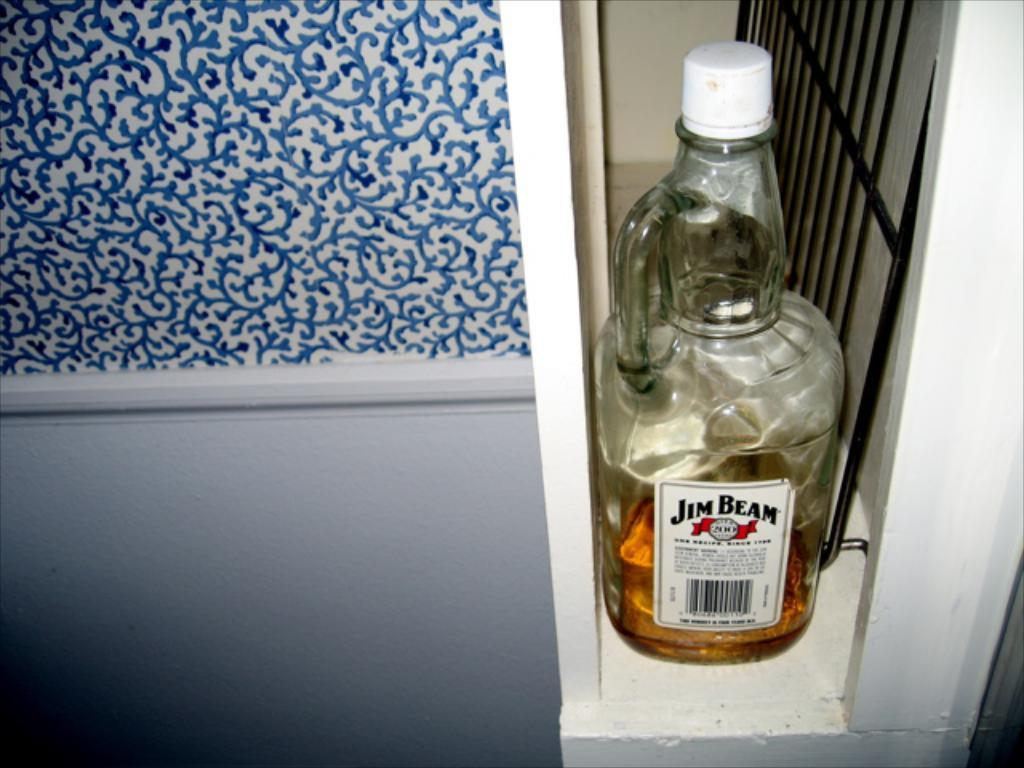<image>
Present a compact description of the photo's key features. A bottle of Jim Bean that is almost finished in a cabinet. 